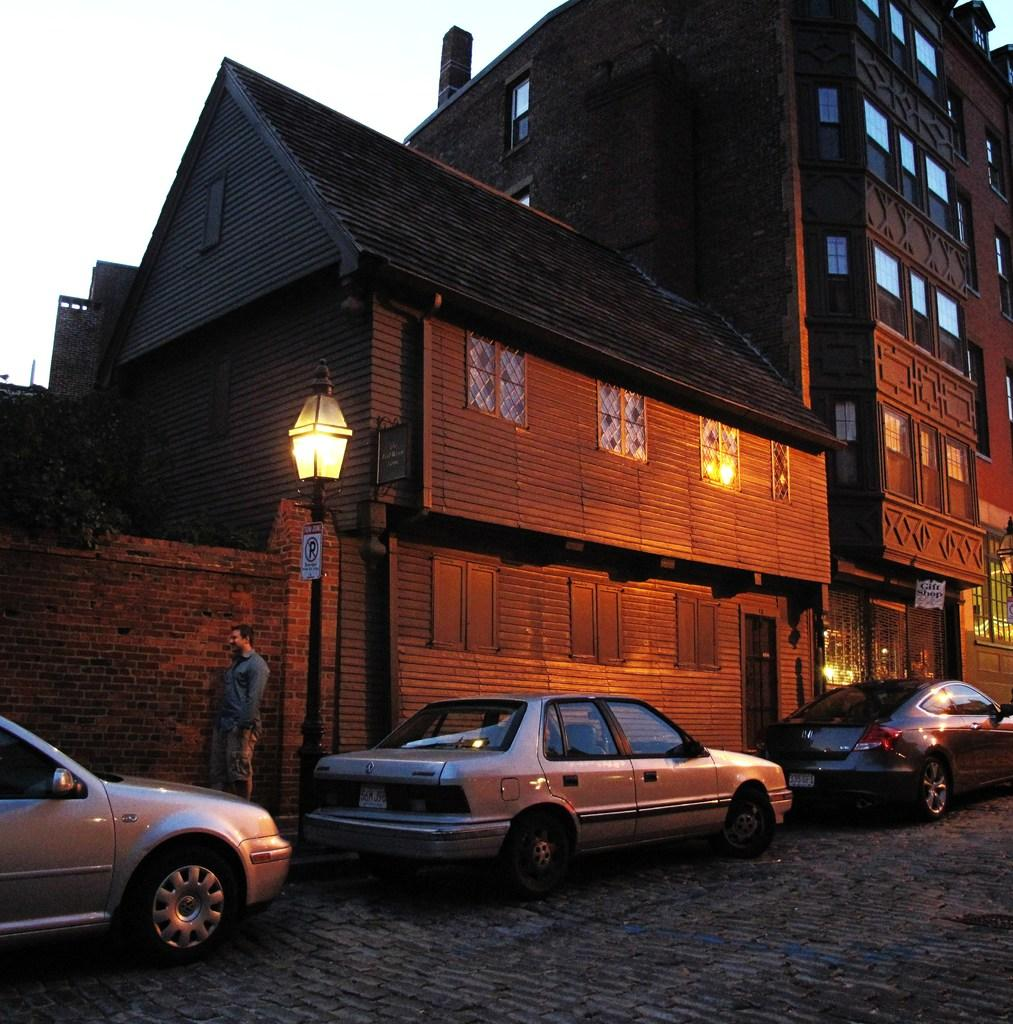What type of structures are visible in the image? There are buildings with windows in the image. What type of vehicles can be seen in the image? There are cars in the image. What type of illumination is present in the image? There are lights in the image. What type of vegetation is present in the image? There are plants in the image. Who or what is present in the image? There is a person in the image. What can be seen in the background of the image? The sky is visible in the background of the image. What type of farm animals can be seen grazing in the image? There are no farm animals present in the image; it features buildings, cars, lights, plants, a person, and the sky. What type of rice is being harvested in the image? There is no rice or harvesting activity present in the image. 